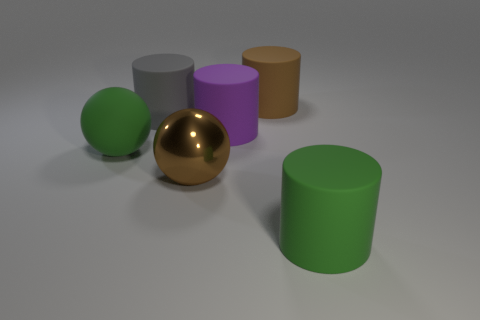Is there any other thing that has the same material as the large brown ball?
Keep it short and to the point. No. Is the number of green spheres on the right side of the purple matte cylinder less than the number of big matte balls?
Give a very brief answer. Yes. Is the big purple rubber thing the same shape as the brown metallic object?
Provide a short and direct response. No. There is a green ball that is made of the same material as the large gray cylinder; what size is it?
Your answer should be very brief. Large. Are there fewer brown cylinders than purple shiny objects?
Your answer should be compact. No. What number of large things are either brown metallic spheres or green metallic cylinders?
Give a very brief answer. 1. What number of big green objects are both behind the big brown metallic object and right of the large purple rubber object?
Make the answer very short. 0. Is the number of gray rubber objects greater than the number of blue cylinders?
Offer a very short reply. Yes. What number of other things are there of the same shape as the brown rubber object?
Keep it short and to the point. 3. Does the large metallic thing have the same color as the big matte ball?
Provide a short and direct response. No. 